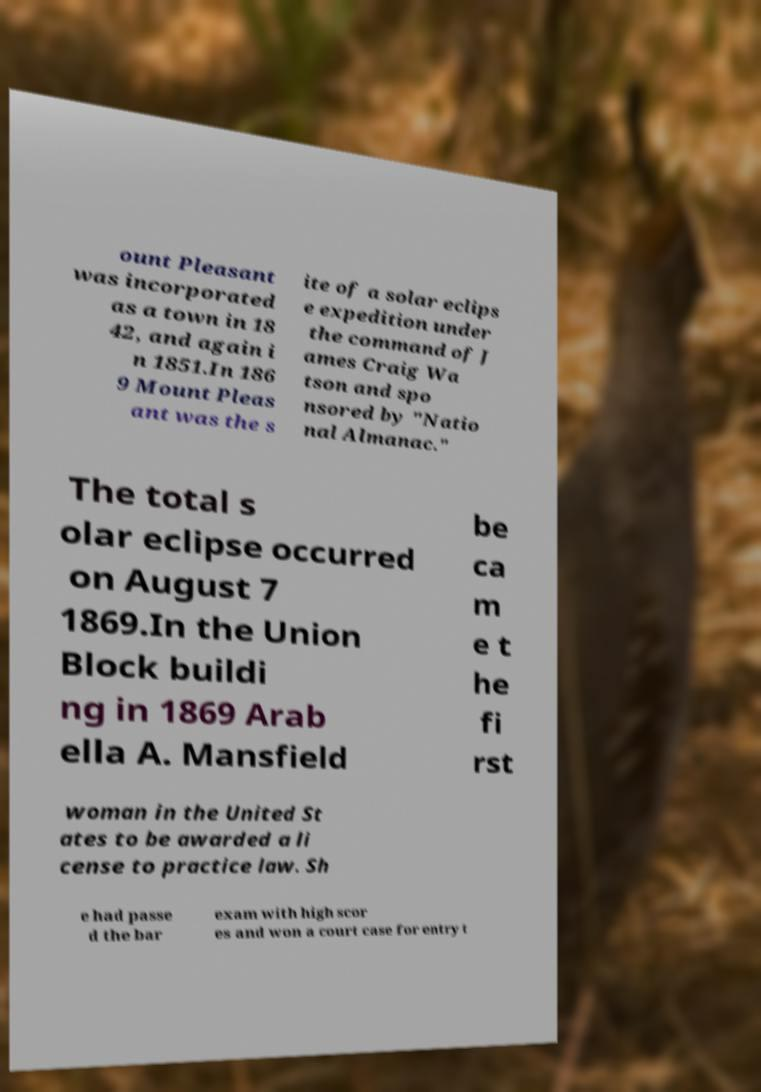Please identify and transcribe the text found in this image. ount Pleasant was incorporated as a town in 18 42, and again i n 1851.In 186 9 Mount Pleas ant was the s ite of a solar eclips e expedition under the command of J ames Craig Wa tson and spo nsored by "Natio nal Almanac." The total s olar eclipse occurred on August 7 1869.In the Union Block buildi ng in 1869 Arab ella A. Mansfield be ca m e t he fi rst woman in the United St ates to be awarded a li cense to practice law. Sh e had passe d the bar exam with high scor es and won a court case for entry t 